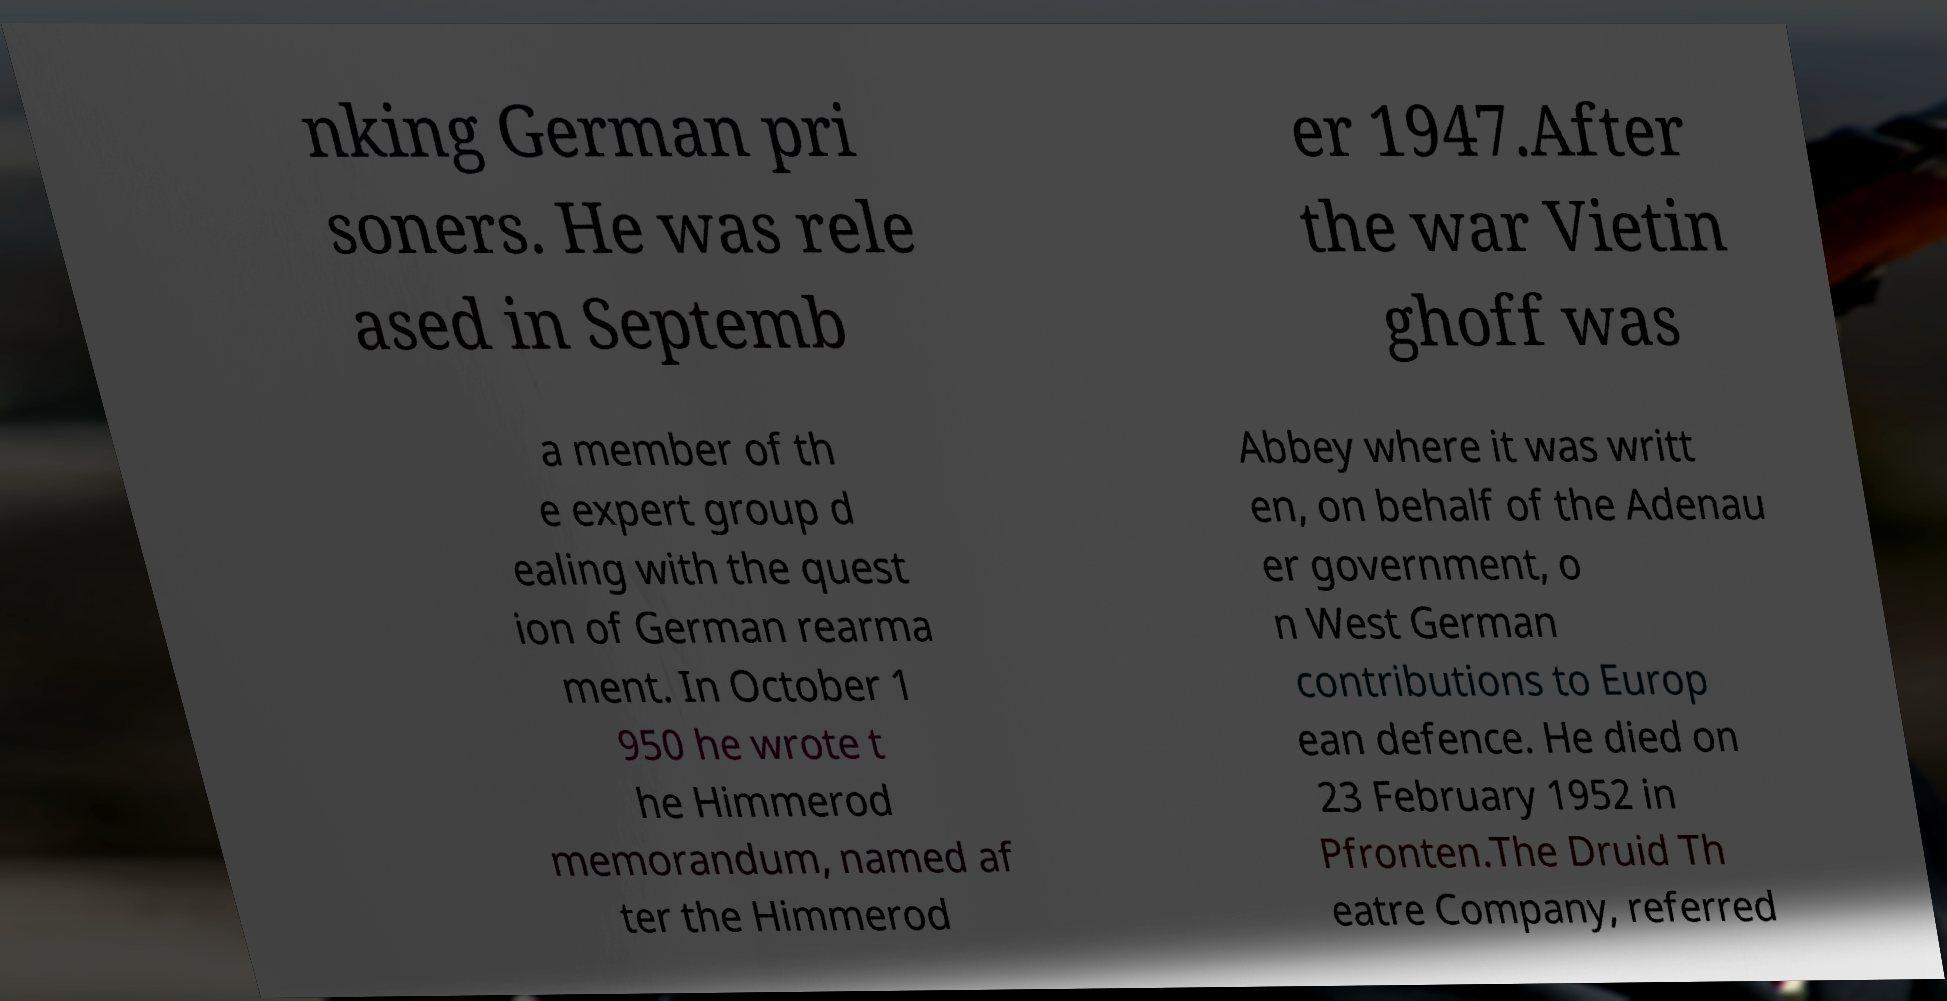For documentation purposes, I need the text within this image transcribed. Could you provide that? nking German pri soners. He was rele ased in Septemb er 1947.After the war Vietin ghoff was a member of th e expert group d ealing with the quest ion of German rearma ment. In October 1 950 he wrote t he Himmerod memorandum, named af ter the Himmerod Abbey where it was writt en, on behalf of the Adenau er government, o n West German contributions to Europ ean defence. He died on 23 February 1952 in Pfronten.The Druid Th eatre Company, referred 